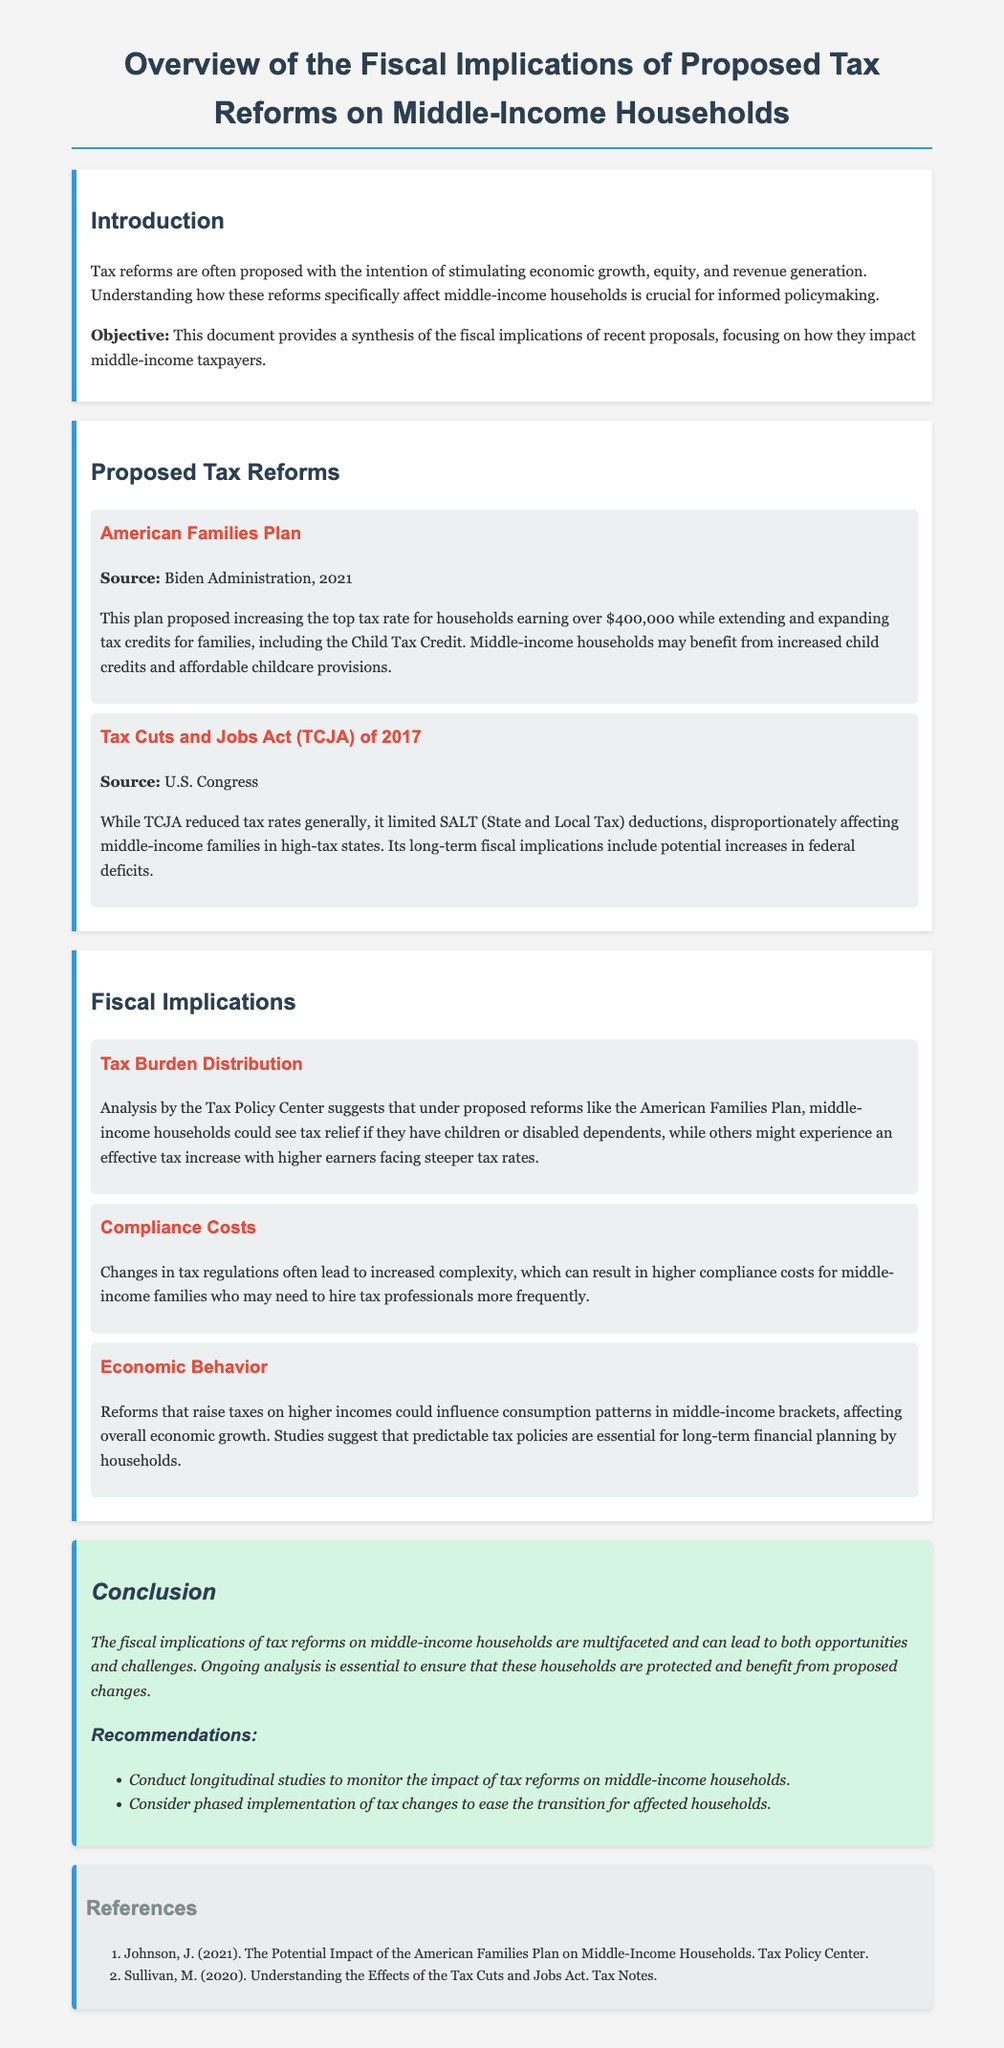What is the title of the document? The title is presented prominently at the top of the document.
Answer: Overview of the Fiscal Implications of Proposed Tax Reforms on Middle-Income Households Who proposed the American Families Plan? The document indicates the source of the American Families Plan.
Answer: Biden Administration In what year was the Tax Cuts and Jobs Act enacted? The date of enactment is mentioned alongside the title of the reform.
Answer: 2017 What tax rate increase is proposed for households earning over what amount in the American Families Plan? The specific income threshold is provided in the description of the reform.
Answer: $400,000 What is one potential benefit of the American Families Plan for middle-income households? The document lists specific benefits for middle-income households under this plan.
Answer: Increased child credits Which tax reforms could lead to increased compliance costs for middle-income families? The implications section discusses the complexity of tax regulations related to reforms.
Answer: Changes in tax regulations How could tax reforms influence economic behavior among middle-income households? The document suggests a relationship between tax reforms and household behavior.
Answer: Affect consumption patterns What type of studies does the conclusion recommend for assessing tax reform impacts? The document provides suggestions for monitoring the effects of tax reforms.
Answer: Longitudinal studies What is a potential challenge mentioned in the conclusion regarding tax reforms for middle-income households? The conclusion summarizes the multifaceted impacts of tax reforms.
Answer: Challenges 